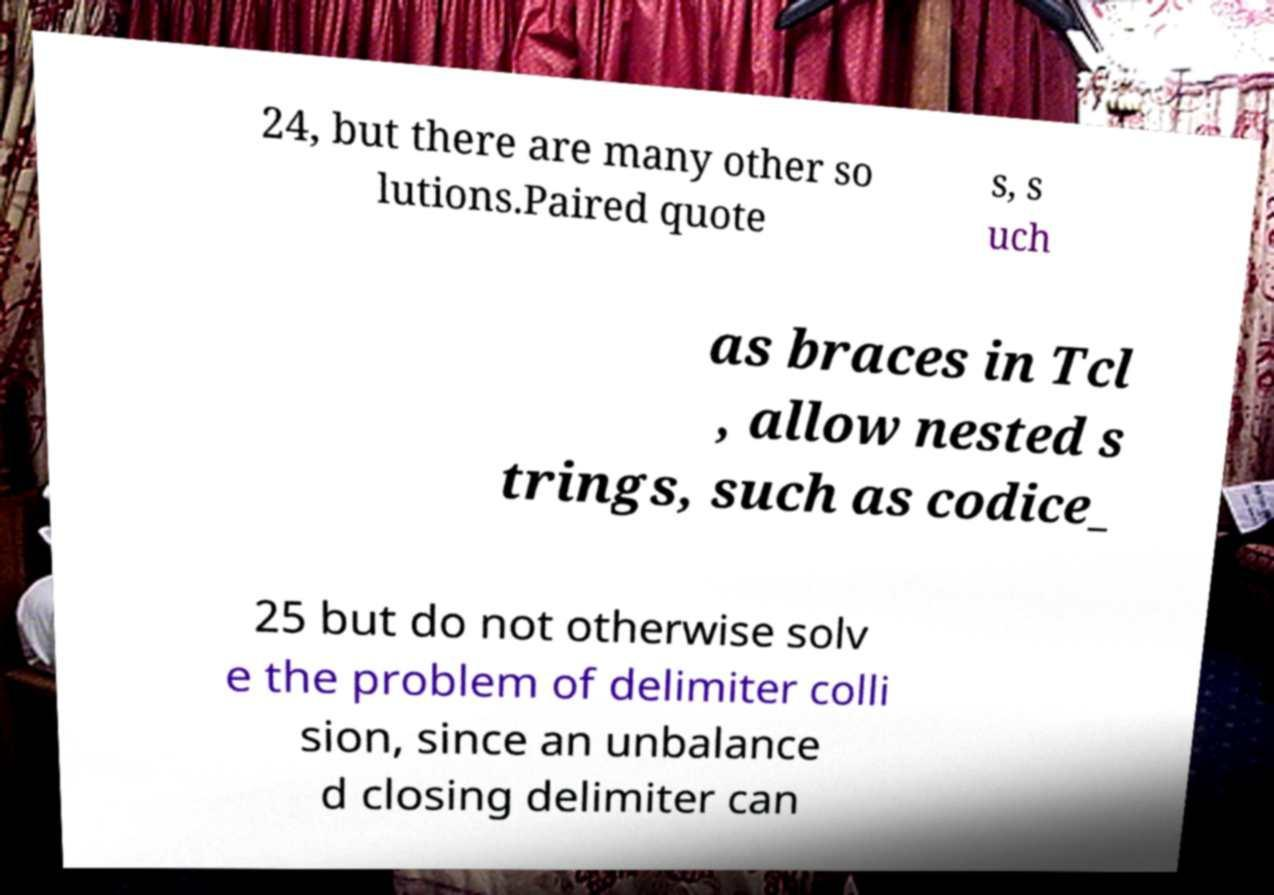Can you accurately transcribe the text from the provided image for me? 24, but there are many other so lutions.Paired quote s, s uch as braces in Tcl , allow nested s trings, such as codice_ 25 but do not otherwise solv e the problem of delimiter colli sion, since an unbalance d closing delimiter can 